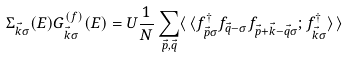<formula> <loc_0><loc_0><loc_500><loc_500>\Sigma _ { \vec { k } \sigma } ( E ) G _ { \vec { k } \sigma } ^ { ( f ) } ( E ) = U \frac { 1 } { N } \sum _ { \vec { p } , \vec { q } } \langle \, \langle f _ { \vec { p } \sigma } ^ { \dagger } f _ { \vec { q } - \sigma } f _ { \vec { p } + \vec { k } - \vec { q } \sigma } ; f _ { \vec { k } \sigma } ^ { \dagger } \rangle \, \rangle</formula> 